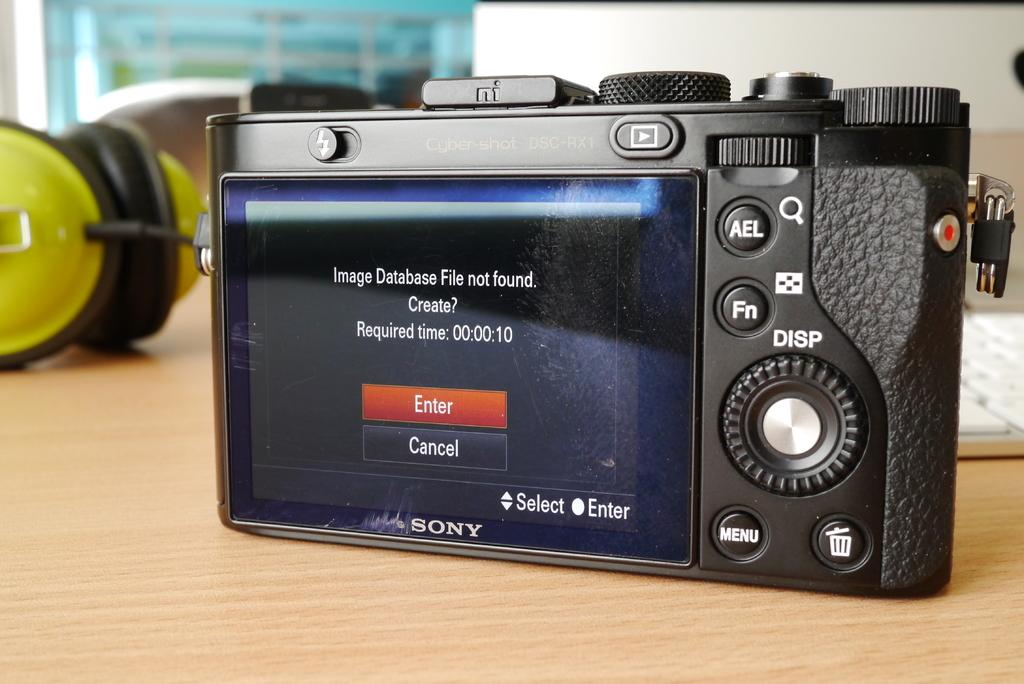What piece of furniture is visible in the image? There is a table in the image. What electronic device is on the table? A camera is present on the table. What other object can be seen on the table? A keyboard is on the table. What is the unspecified object on the table? There is an unspecified object on the table. What is visible at the top of the image? There is a wall visible at the top of the image. What is the price of the impulse that can be seen on the table? There is no impulse present on the table, so it is not possible to determine its price. 